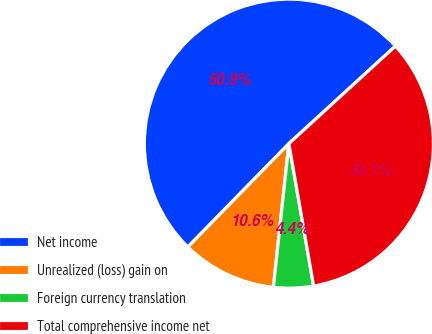Convert chart. <chart><loc_0><loc_0><loc_500><loc_500><pie_chart><fcel>Net income<fcel>Unrealized (loss) gain on<fcel>Foreign currency translation<fcel>Total comprehensive income net<nl><fcel>50.88%<fcel>10.61%<fcel>4.45%<fcel>34.06%<nl></chart> 